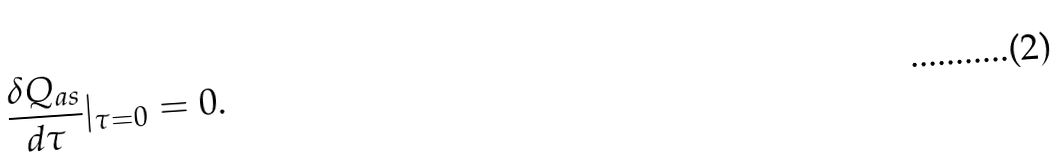<formula> <loc_0><loc_0><loc_500><loc_500>\frac { \delta Q _ { a s } } { d \tau } | _ { \tau = 0 } = 0 .</formula> 